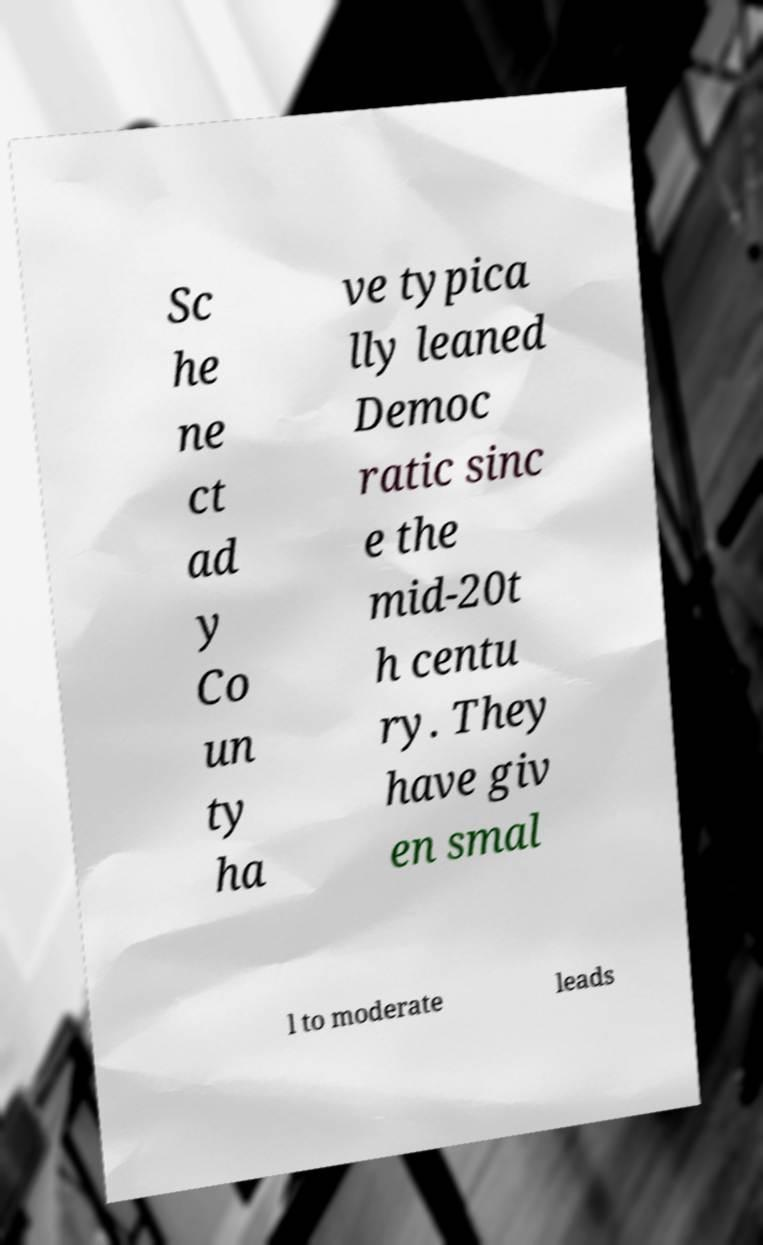There's text embedded in this image that I need extracted. Can you transcribe it verbatim? Sc he ne ct ad y Co un ty ha ve typica lly leaned Democ ratic sinc e the mid-20t h centu ry. They have giv en smal l to moderate leads 